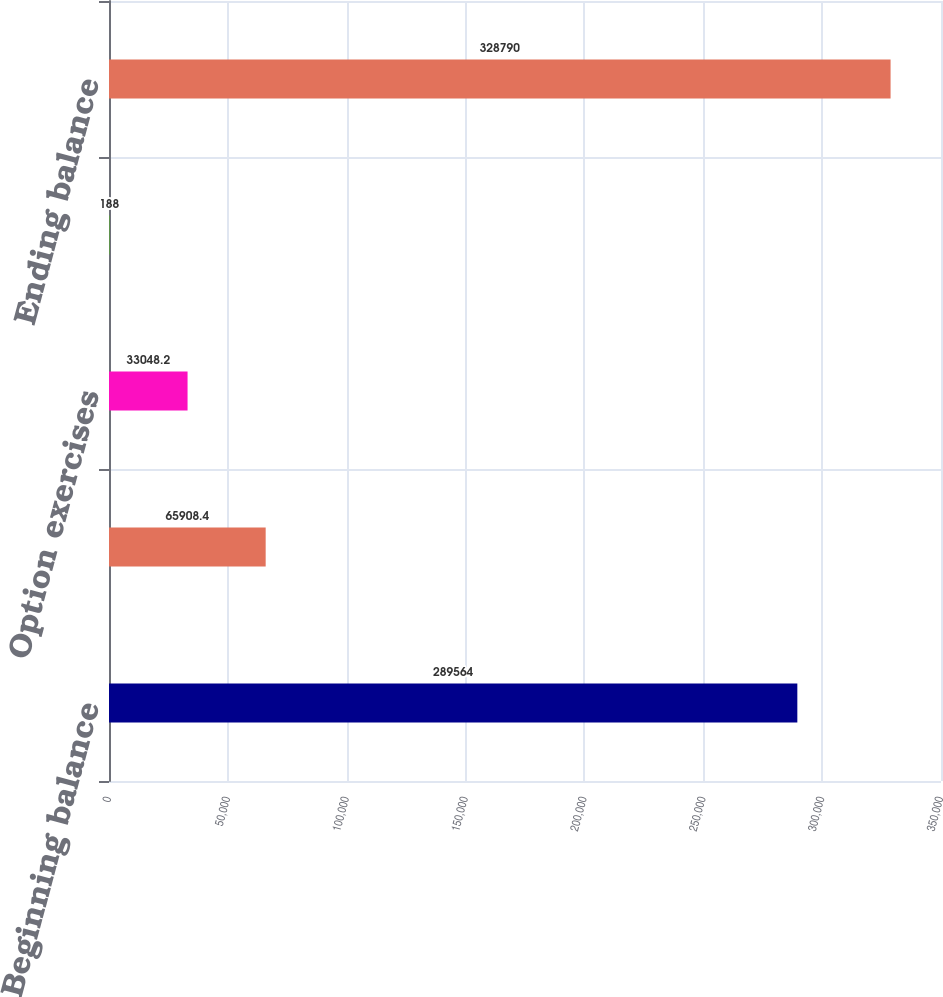<chart> <loc_0><loc_0><loc_500><loc_500><bar_chart><fcel>Beginning balance<fcel>Dividend reinvestment plan<fcel>Option exercises<fcel>Other net<fcel>Ending balance<nl><fcel>289564<fcel>65908.4<fcel>33048.2<fcel>188<fcel>328790<nl></chart> 